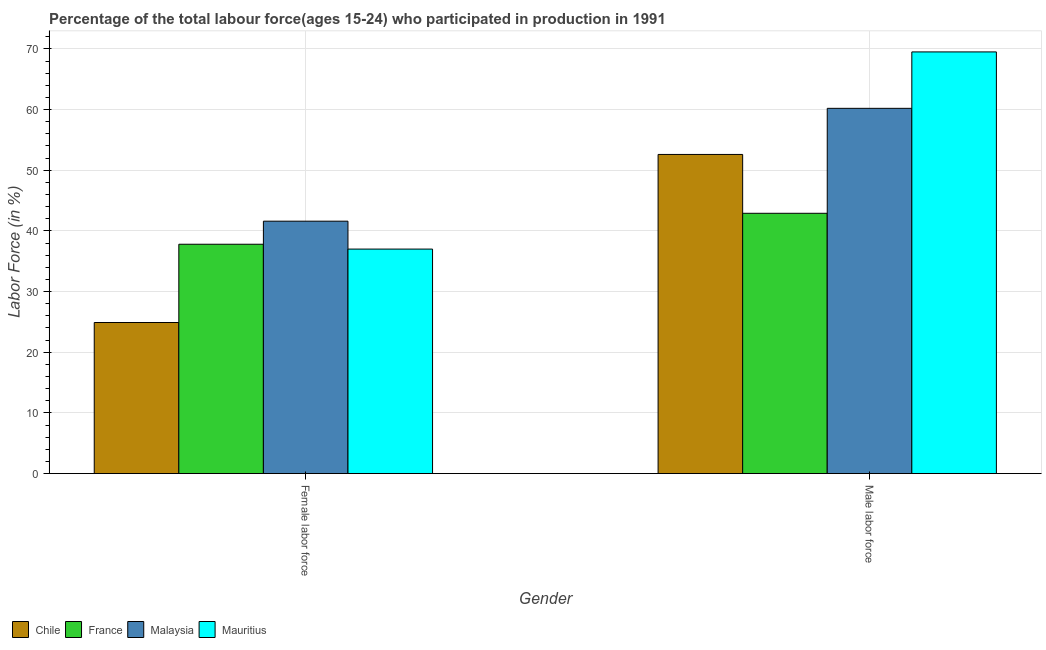Are the number of bars per tick equal to the number of legend labels?
Offer a very short reply. Yes. How many bars are there on the 2nd tick from the left?
Your answer should be very brief. 4. What is the label of the 1st group of bars from the left?
Provide a short and direct response. Female labor force. What is the percentage of male labour force in Chile?
Your response must be concise. 52.6. Across all countries, what is the maximum percentage of male labour force?
Give a very brief answer. 69.5. Across all countries, what is the minimum percentage of male labour force?
Your response must be concise. 42.9. In which country was the percentage of female labor force maximum?
Make the answer very short. Malaysia. In which country was the percentage of female labor force minimum?
Offer a very short reply. Chile. What is the total percentage of male labour force in the graph?
Make the answer very short. 225.2. What is the difference between the percentage of male labour force in France and that in Malaysia?
Offer a very short reply. -17.3. What is the difference between the percentage of female labor force in Mauritius and the percentage of male labour force in Chile?
Your answer should be compact. -15.6. What is the average percentage of female labor force per country?
Provide a succinct answer. 35.32. What is the difference between the percentage of female labor force and percentage of male labour force in Mauritius?
Offer a very short reply. -32.5. What is the ratio of the percentage of female labor force in Malaysia to that in Mauritius?
Provide a succinct answer. 1.12. How many bars are there?
Ensure brevity in your answer.  8. Are all the bars in the graph horizontal?
Keep it short and to the point. No. What is the difference between two consecutive major ticks on the Y-axis?
Offer a terse response. 10. Are the values on the major ticks of Y-axis written in scientific E-notation?
Your answer should be very brief. No. How are the legend labels stacked?
Provide a succinct answer. Horizontal. What is the title of the graph?
Give a very brief answer. Percentage of the total labour force(ages 15-24) who participated in production in 1991. Does "Italy" appear as one of the legend labels in the graph?
Your response must be concise. No. What is the Labor Force (in %) in Chile in Female labor force?
Keep it short and to the point. 24.9. What is the Labor Force (in %) of France in Female labor force?
Your answer should be compact. 37.8. What is the Labor Force (in %) of Malaysia in Female labor force?
Provide a succinct answer. 41.6. What is the Labor Force (in %) of Mauritius in Female labor force?
Your answer should be very brief. 37. What is the Labor Force (in %) in Chile in Male labor force?
Offer a very short reply. 52.6. What is the Labor Force (in %) of France in Male labor force?
Offer a terse response. 42.9. What is the Labor Force (in %) in Malaysia in Male labor force?
Provide a succinct answer. 60.2. What is the Labor Force (in %) in Mauritius in Male labor force?
Offer a very short reply. 69.5. Across all Gender, what is the maximum Labor Force (in %) of Chile?
Your answer should be compact. 52.6. Across all Gender, what is the maximum Labor Force (in %) of France?
Offer a very short reply. 42.9. Across all Gender, what is the maximum Labor Force (in %) in Malaysia?
Your answer should be very brief. 60.2. Across all Gender, what is the maximum Labor Force (in %) of Mauritius?
Keep it short and to the point. 69.5. Across all Gender, what is the minimum Labor Force (in %) in Chile?
Ensure brevity in your answer.  24.9. Across all Gender, what is the minimum Labor Force (in %) of France?
Offer a terse response. 37.8. Across all Gender, what is the minimum Labor Force (in %) of Malaysia?
Ensure brevity in your answer.  41.6. What is the total Labor Force (in %) in Chile in the graph?
Keep it short and to the point. 77.5. What is the total Labor Force (in %) of France in the graph?
Offer a very short reply. 80.7. What is the total Labor Force (in %) in Malaysia in the graph?
Ensure brevity in your answer.  101.8. What is the total Labor Force (in %) in Mauritius in the graph?
Give a very brief answer. 106.5. What is the difference between the Labor Force (in %) in Chile in Female labor force and that in Male labor force?
Your answer should be very brief. -27.7. What is the difference between the Labor Force (in %) of Malaysia in Female labor force and that in Male labor force?
Your response must be concise. -18.6. What is the difference between the Labor Force (in %) in Mauritius in Female labor force and that in Male labor force?
Offer a very short reply. -32.5. What is the difference between the Labor Force (in %) of Chile in Female labor force and the Labor Force (in %) of France in Male labor force?
Ensure brevity in your answer.  -18. What is the difference between the Labor Force (in %) of Chile in Female labor force and the Labor Force (in %) of Malaysia in Male labor force?
Give a very brief answer. -35.3. What is the difference between the Labor Force (in %) in Chile in Female labor force and the Labor Force (in %) in Mauritius in Male labor force?
Provide a short and direct response. -44.6. What is the difference between the Labor Force (in %) in France in Female labor force and the Labor Force (in %) in Malaysia in Male labor force?
Give a very brief answer. -22.4. What is the difference between the Labor Force (in %) of France in Female labor force and the Labor Force (in %) of Mauritius in Male labor force?
Ensure brevity in your answer.  -31.7. What is the difference between the Labor Force (in %) in Malaysia in Female labor force and the Labor Force (in %) in Mauritius in Male labor force?
Ensure brevity in your answer.  -27.9. What is the average Labor Force (in %) of Chile per Gender?
Your response must be concise. 38.75. What is the average Labor Force (in %) in France per Gender?
Make the answer very short. 40.35. What is the average Labor Force (in %) of Malaysia per Gender?
Your response must be concise. 50.9. What is the average Labor Force (in %) in Mauritius per Gender?
Offer a very short reply. 53.25. What is the difference between the Labor Force (in %) of Chile and Labor Force (in %) of France in Female labor force?
Provide a short and direct response. -12.9. What is the difference between the Labor Force (in %) in Chile and Labor Force (in %) in Malaysia in Female labor force?
Offer a very short reply. -16.7. What is the difference between the Labor Force (in %) of Chile and Labor Force (in %) of France in Male labor force?
Provide a succinct answer. 9.7. What is the difference between the Labor Force (in %) in Chile and Labor Force (in %) in Malaysia in Male labor force?
Offer a very short reply. -7.6. What is the difference between the Labor Force (in %) of Chile and Labor Force (in %) of Mauritius in Male labor force?
Provide a short and direct response. -16.9. What is the difference between the Labor Force (in %) of France and Labor Force (in %) of Malaysia in Male labor force?
Offer a very short reply. -17.3. What is the difference between the Labor Force (in %) of France and Labor Force (in %) of Mauritius in Male labor force?
Offer a terse response. -26.6. What is the ratio of the Labor Force (in %) of Chile in Female labor force to that in Male labor force?
Offer a very short reply. 0.47. What is the ratio of the Labor Force (in %) in France in Female labor force to that in Male labor force?
Offer a very short reply. 0.88. What is the ratio of the Labor Force (in %) in Malaysia in Female labor force to that in Male labor force?
Keep it short and to the point. 0.69. What is the ratio of the Labor Force (in %) in Mauritius in Female labor force to that in Male labor force?
Make the answer very short. 0.53. What is the difference between the highest and the second highest Labor Force (in %) in Chile?
Offer a terse response. 27.7. What is the difference between the highest and the second highest Labor Force (in %) in France?
Provide a short and direct response. 5.1. What is the difference between the highest and the second highest Labor Force (in %) of Mauritius?
Your response must be concise. 32.5. What is the difference between the highest and the lowest Labor Force (in %) of Chile?
Make the answer very short. 27.7. What is the difference between the highest and the lowest Labor Force (in %) of Mauritius?
Give a very brief answer. 32.5. 